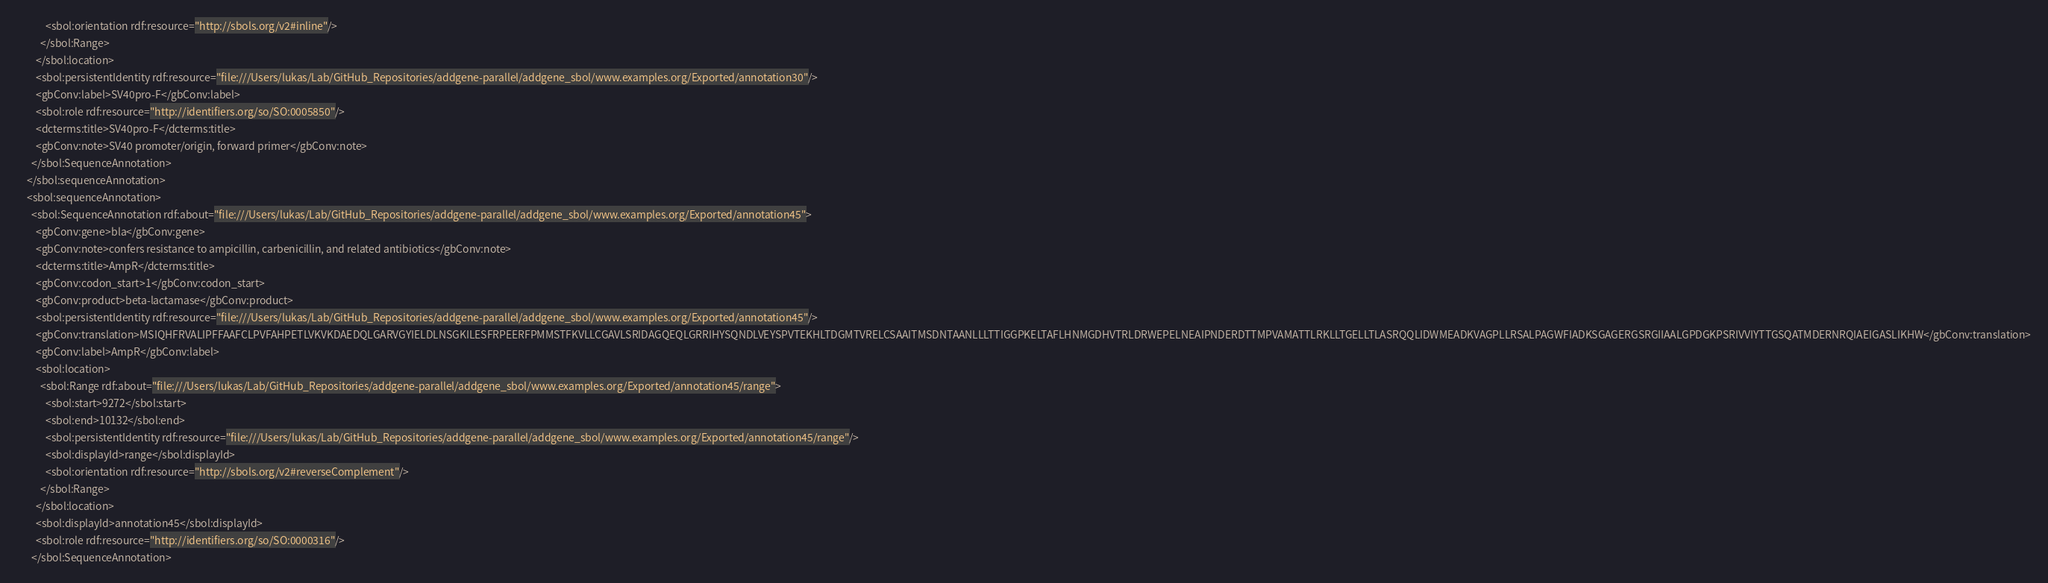Convert code to text. <code><loc_0><loc_0><loc_500><loc_500><_XML_>            <sbol:orientation rdf:resource="http://sbols.org/v2#inline"/>
          </sbol:Range>
        </sbol:location>
        <sbol:persistentIdentity rdf:resource="file:///Users/lukas/Lab/GitHub_Repositories/addgene-parallel/addgene_sbol/www.examples.org/Exported/annotation30"/>
        <gbConv:label>SV40pro-F</gbConv:label>
        <sbol:role rdf:resource="http://identifiers.org/so/SO:0005850"/>
        <dcterms:title>SV40pro-F</dcterms:title>
        <gbConv:note>SV40 promoter/origin, forward primer</gbConv:note>
      </sbol:SequenceAnnotation>
    </sbol:sequenceAnnotation>
    <sbol:sequenceAnnotation>
      <sbol:SequenceAnnotation rdf:about="file:///Users/lukas/Lab/GitHub_Repositories/addgene-parallel/addgene_sbol/www.examples.org/Exported/annotation45">
        <gbConv:gene>bla</gbConv:gene>
        <gbConv:note>confers resistance to ampicillin, carbenicillin, and related antibiotics</gbConv:note>
        <dcterms:title>AmpR</dcterms:title>
        <gbConv:codon_start>1</gbConv:codon_start>
        <gbConv:product>beta-lactamase</gbConv:product>
        <sbol:persistentIdentity rdf:resource="file:///Users/lukas/Lab/GitHub_Repositories/addgene-parallel/addgene_sbol/www.examples.org/Exported/annotation45"/>
        <gbConv:translation>MSIQHFRVALIPFFAAFCLPVFAHPETLVKVKDAEDQLGARVGYIELDLNSGKILESFRPEERFPMMSTFKVLLCGAVLSRIDAGQEQLGRRIHYSQNDLVEYSPVTEKHLTDGMTVRELCSAAITMSDNTAANLLLTTIGGPKELTAFLHNMGDHVTRLDRWEPELNEAIPNDERDTTMPVAMATTLRKLLTGELLTLASRQQLIDWMEADKVAGPLLRSALPAGWFIADKSGAGERGSRGIIAALGPDGKPSRIVVIYTTGSQATMDERNRQIAEIGASLIKHW</gbConv:translation>
        <gbConv:label>AmpR</gbConv:label>
        <sbol:location>
          <sbol:Range rdf:about="file:///Users/lukas/Lab/GitHub_Repositories/addgene-parallel/addgene_sbol/www.examples.org/Exported/annotation45/range">
            <sbol:start>9272</sbol:start>
            <sbol:end>10132</sbol:end>
            <sbol:persistentIdentity rdf:resource="file:///Users/lukas/Lab/GitHub_Repositories/addgene-parallel/addgene_sbol/www.examples.org/Exported/annotation45/range"/>
            <sbol:displayId>range</sbol:displayId>
            <sbol:orientation rdf:resource="http://sbols.org/v2#reverseComplement"/>
          </sbol:Range>
        </sbol:location>
        <sbol:displayId>annotation45</sbol:displayId>
        <sbol:role rdf:resource="http://identifiers.org/so/SO:0000316"/>
      </sbol:SequenceAnnotation></code> 